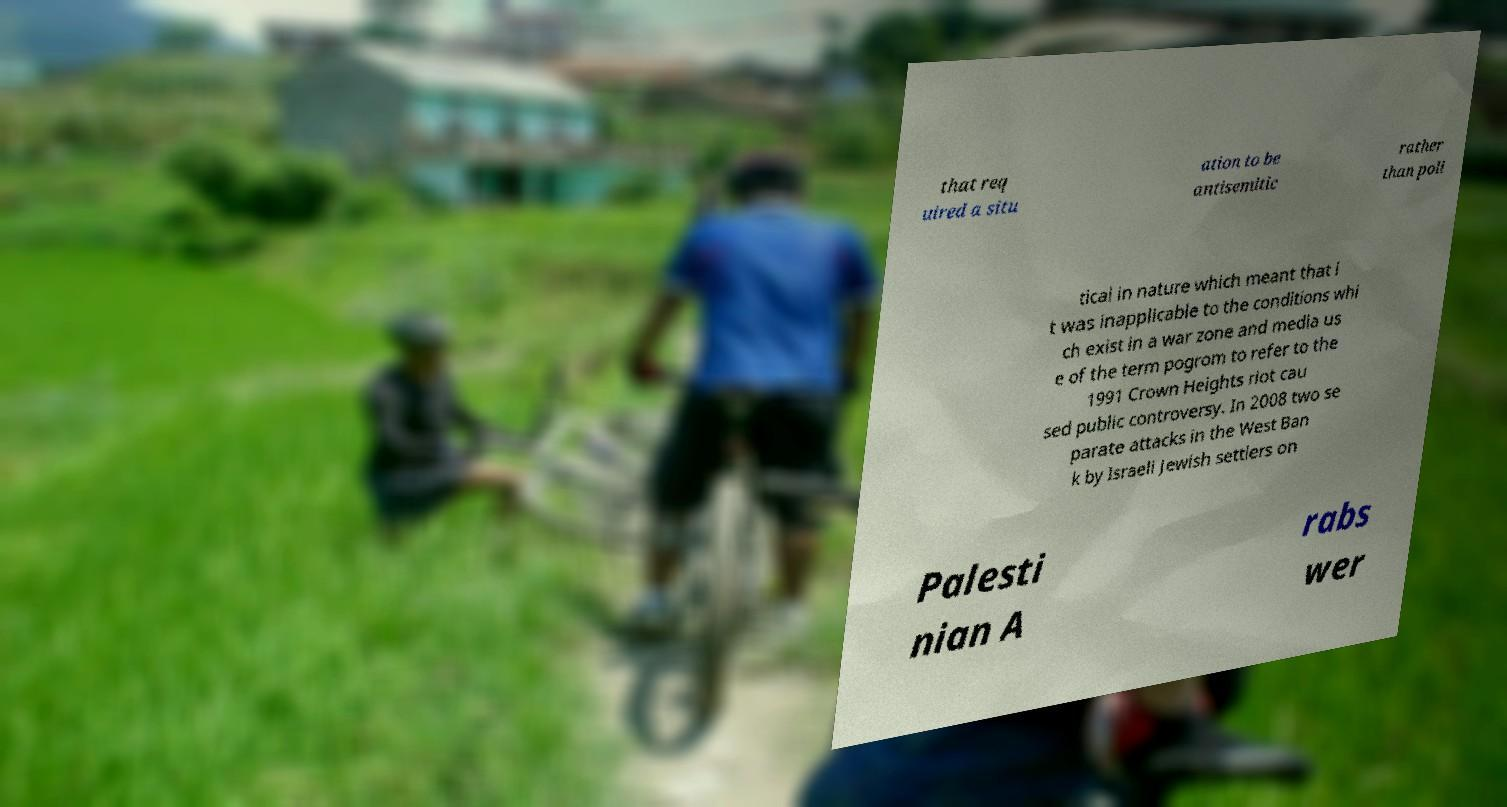Could you extract and type out the text from this image? that req uired a situ ation to be antisemitic rather than poli tical in nature which meant that i t was inapplicable to the conditions whi ch exist in a war zone and media us e of the term pogrom to refer to the 1991 Crown Heights riot cau sed public controversy. In 2008 two se parate attacks in the West Ban k by Israeli Jewish settlers on Palesti nian A rabs wer 